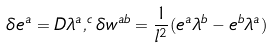Convert formula to latex. <formula><loc_0><loc_0><loc_500><loc_500>\delta e ^ { a } = D \lambda ^ { a } , ^ { c } \delta w ^ { a b } = \frac { 1 } { l ^ { 2 } } ( e ^ { a } \lambda ^ { b } - e ^ { b } \lambda ^ { a } )</formula> 